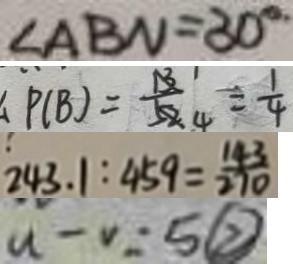Convert formula to latex. <formula><loc_0><loc_0><loc_500><loc_500>\angle A B N = 3 0 ^ { \circ } 
 P ( B ) = \frac { 1 } { 4 } = \frac { 1 } { 4 } 
 2 4 3 . 1 : 4 5 9 = \frac { 1 4 3 } { 2 7 0 } 
 u - v = 5 \textcircled { 2 }</formula> 